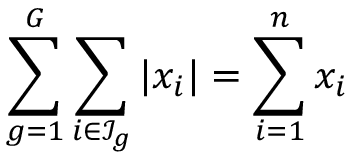Convert formula to latex. <formula><loc_0><loc_0><loc_500><loc_500>\sum _ { g = 1 } ^ { G } \sum _ { i \in \mathcal { I } _ { g } } | x _ { i } | = \sum _ { i = 1 } ^ { n } x _ { i }</formula> 